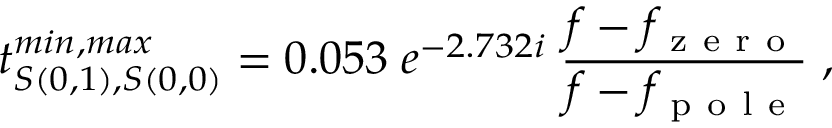<formula> <loc_0><loc_0><loc_500><loc_500>t _ { S ( 0 , 1 ) , S ( 0 , 0 ) } ^ { \min , \max } = 0 . 0 5 3 \, e ^ { - 2 . 7 3 2 i } \, \frac { f - f _ { z e r o } } { f - f _ { p o l e } } \, ,</formula> 